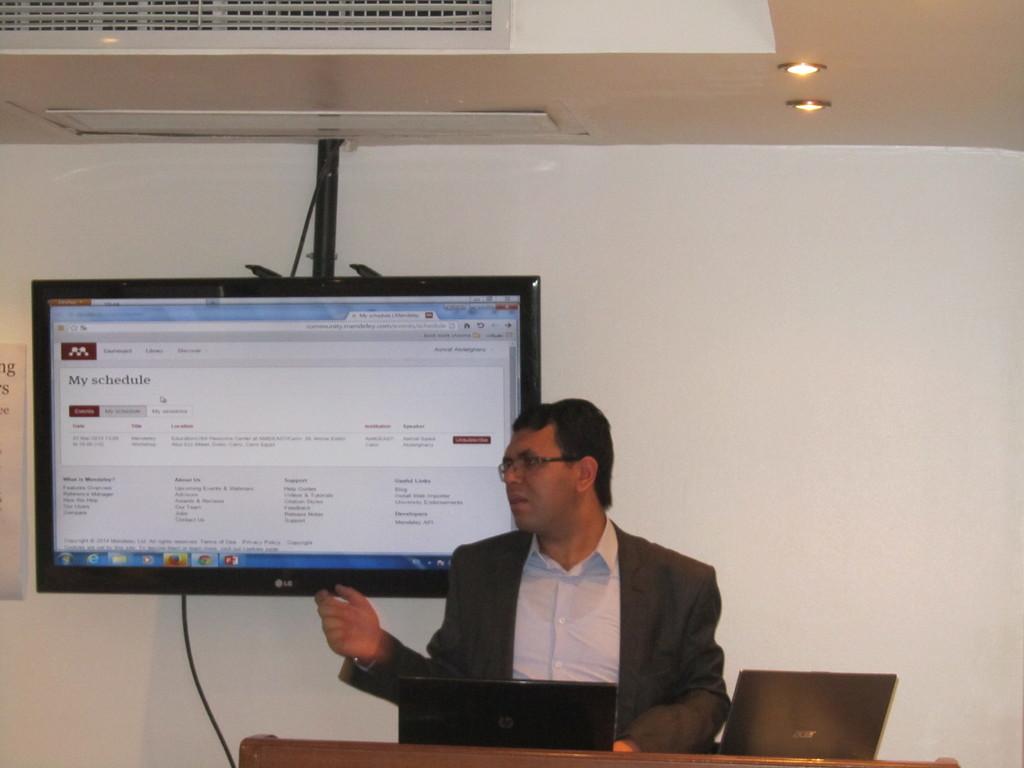What does the webpage show?
Offer a terse response. My schedule. 